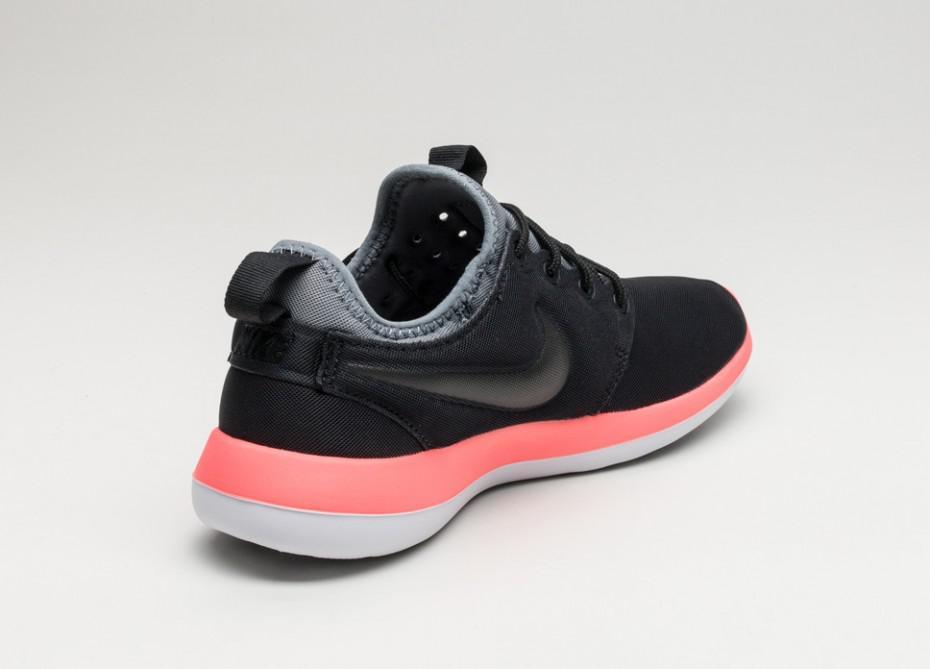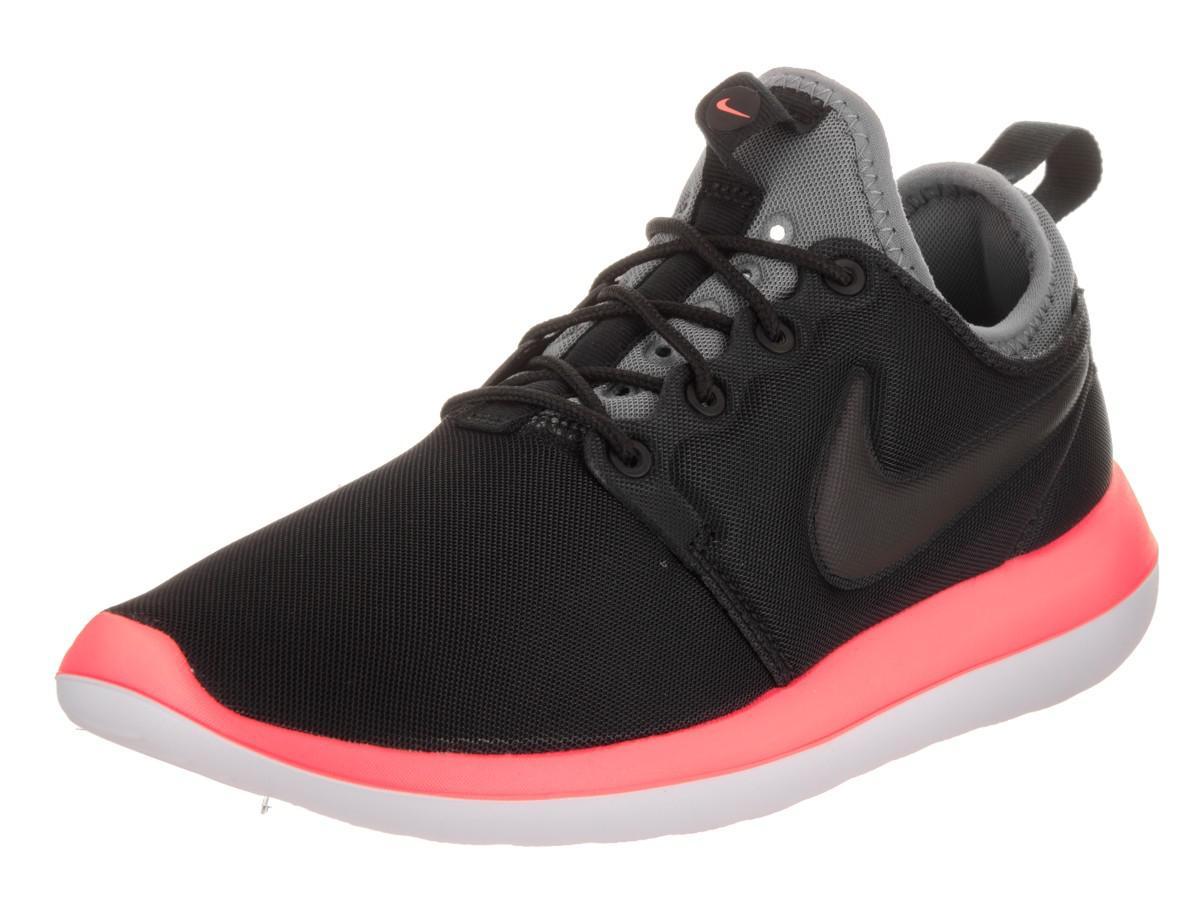The first image is the image on the left, the second image is the image on the right. Given the left and right images, does the statement "Each set features shoes that are dramatically different in color or design." hold true? Answer yes or no. No. The first image is the image on the left, the second image is the image on the right. Evaluate the accuracy of this statement regarding the images: "Both shoes have a gray tongue.". Is it true? Answer yes or no. Yes. 